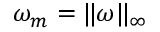<formula> <loc_0><loc_0><loc_500><loc_500>\omega _ { m } = \| \omega \| _ { \infty }</formula> 